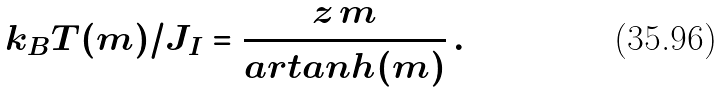<formula> <loc_0><loc_0><loc_500><loc_500>k _ { B } T ( m ) / J _ { I } = \frac { z \, m } { { a r t a n h } ( m ) } \, .</formula> 